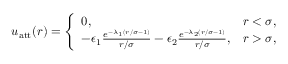<formula> <loc_0><loc_0><loc_500><loc_500>\begin{array} { r } { u _ { a t t } ( r ) = \left \{ \begin{array} { l l } { 0 , \quad } & { r < \sigma , } \\ { - \epsilon _ { 1 } \frac { e ^ { - \lambda _ { 1 } ( r / \sigma - 1 ) } } { r / \sigma } - \epsilon _ { 2 } \frac { e ^ { - \lambda _ { 2 } ( r / \sigma - 1 ) } } { r / \sigma } , } & { r > \sigma , } \end{array} } \end{array}</formula> 